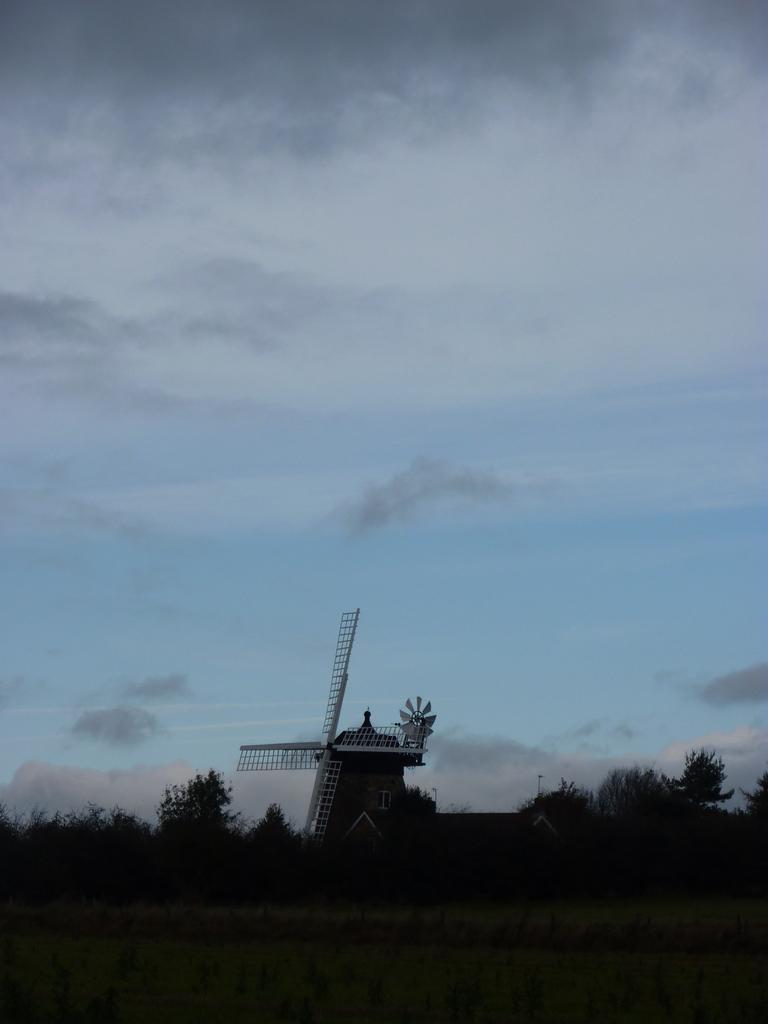Where was the image taken? The image was clicked outside. What is the main structure visible in the image? There is a windmill in the image. What type of vegetation can be seen in the image? There are trees and plants in the image. What is visible in the sky in the image? There are clouds in the sky. Can you see your brother holding a bottle in the image? There is no brother or bottle present in the image. 